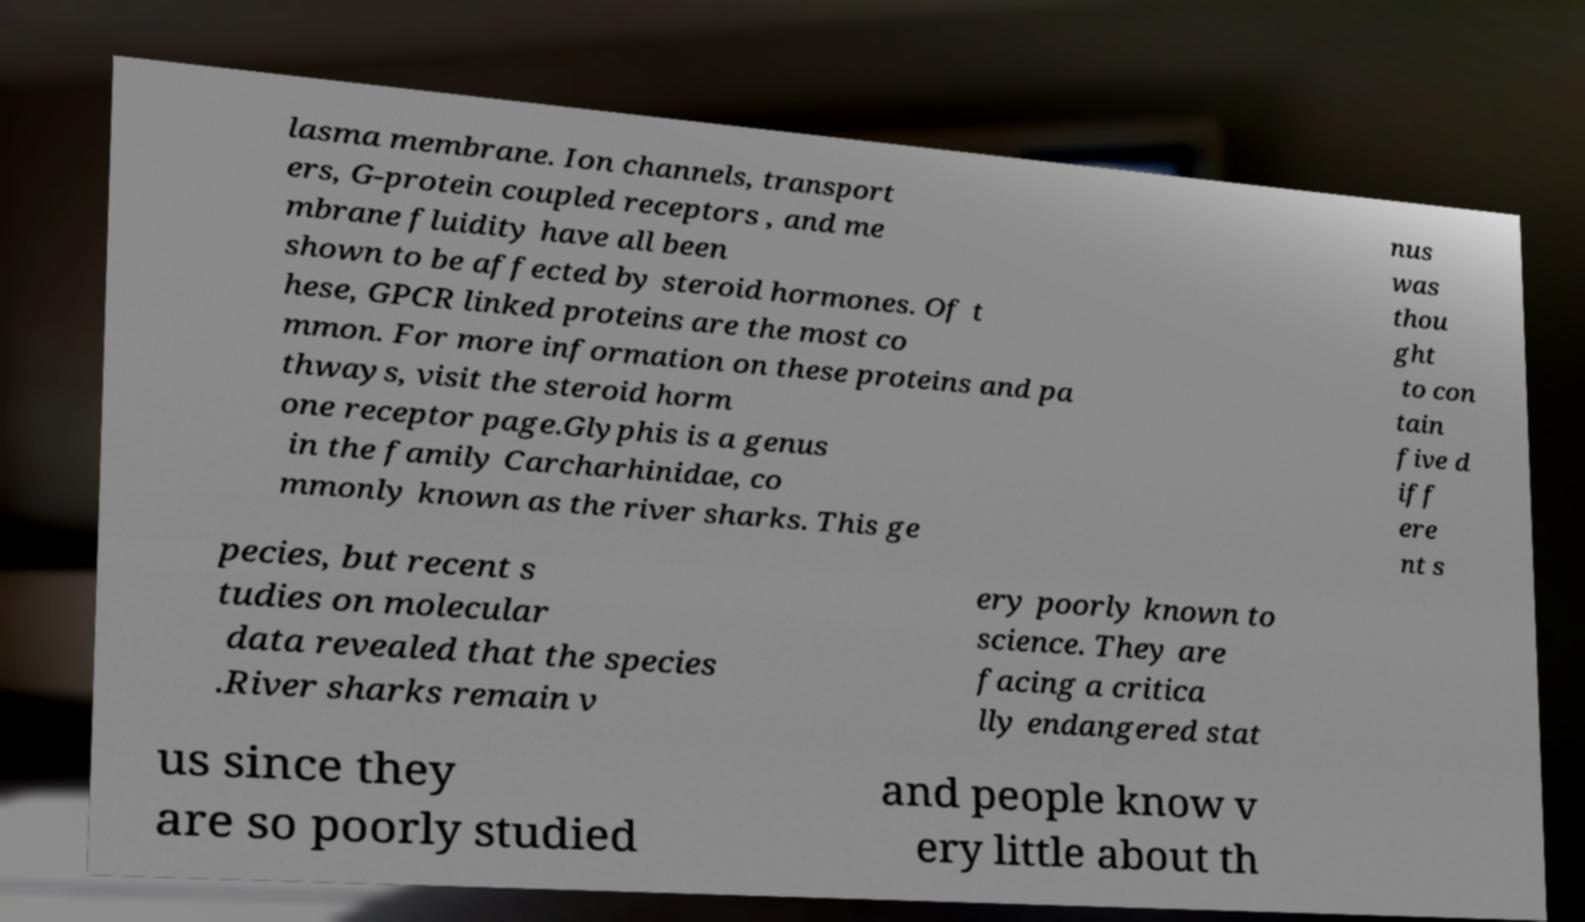What messages or text are displayed in this image? I need them in a readable, typed format. lasma membrane. Ion channels, transport ers, G-protein coupled receptors , and me mbrane fluidity have all been shown to be affected by steroid hormones. Of t hese, GPCR linked proteins are the most co mmon. For more information on these proteins and pa thways, visit the steroid horm one receptor page.Glyphis is a genus in the family Carcharhinidae, co mmonly known as the river sharks. This ge nus was thou ght to con tain five d iff ere nt s pecies, but recent s tudies on molecular data revealed that the species .River sharks remain v ery poorly known to science. They are facing a critica lly endangered stat us since they are so poorly studied and people know v ery little about th 